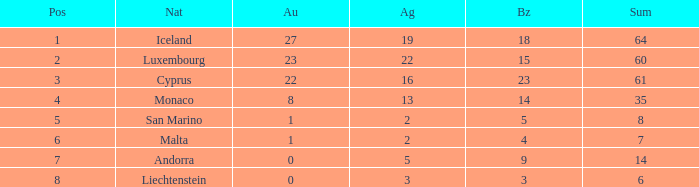Where does Iceland rank with under 19 silvers? None. 